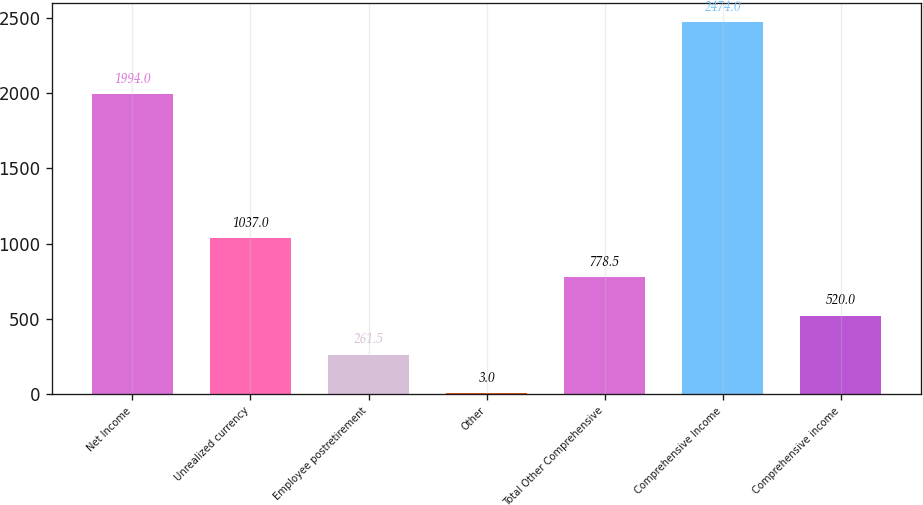<chart> <loc_0><loc_0><loc_500><loc_500><bar_chart><fcel>Net Income<fcel>Unrealized currency<fcel>Employee postretirement<fcel>Other<fcel>Total Other Comprehensive<fcel>Comprehensive Income<fcel>Comprehensive income<nl><fcel>1994<fcel>1037<fcel>261.5<fcel>3<fcel>778.5<fcel>2474<fcel>520<nl></chart> 